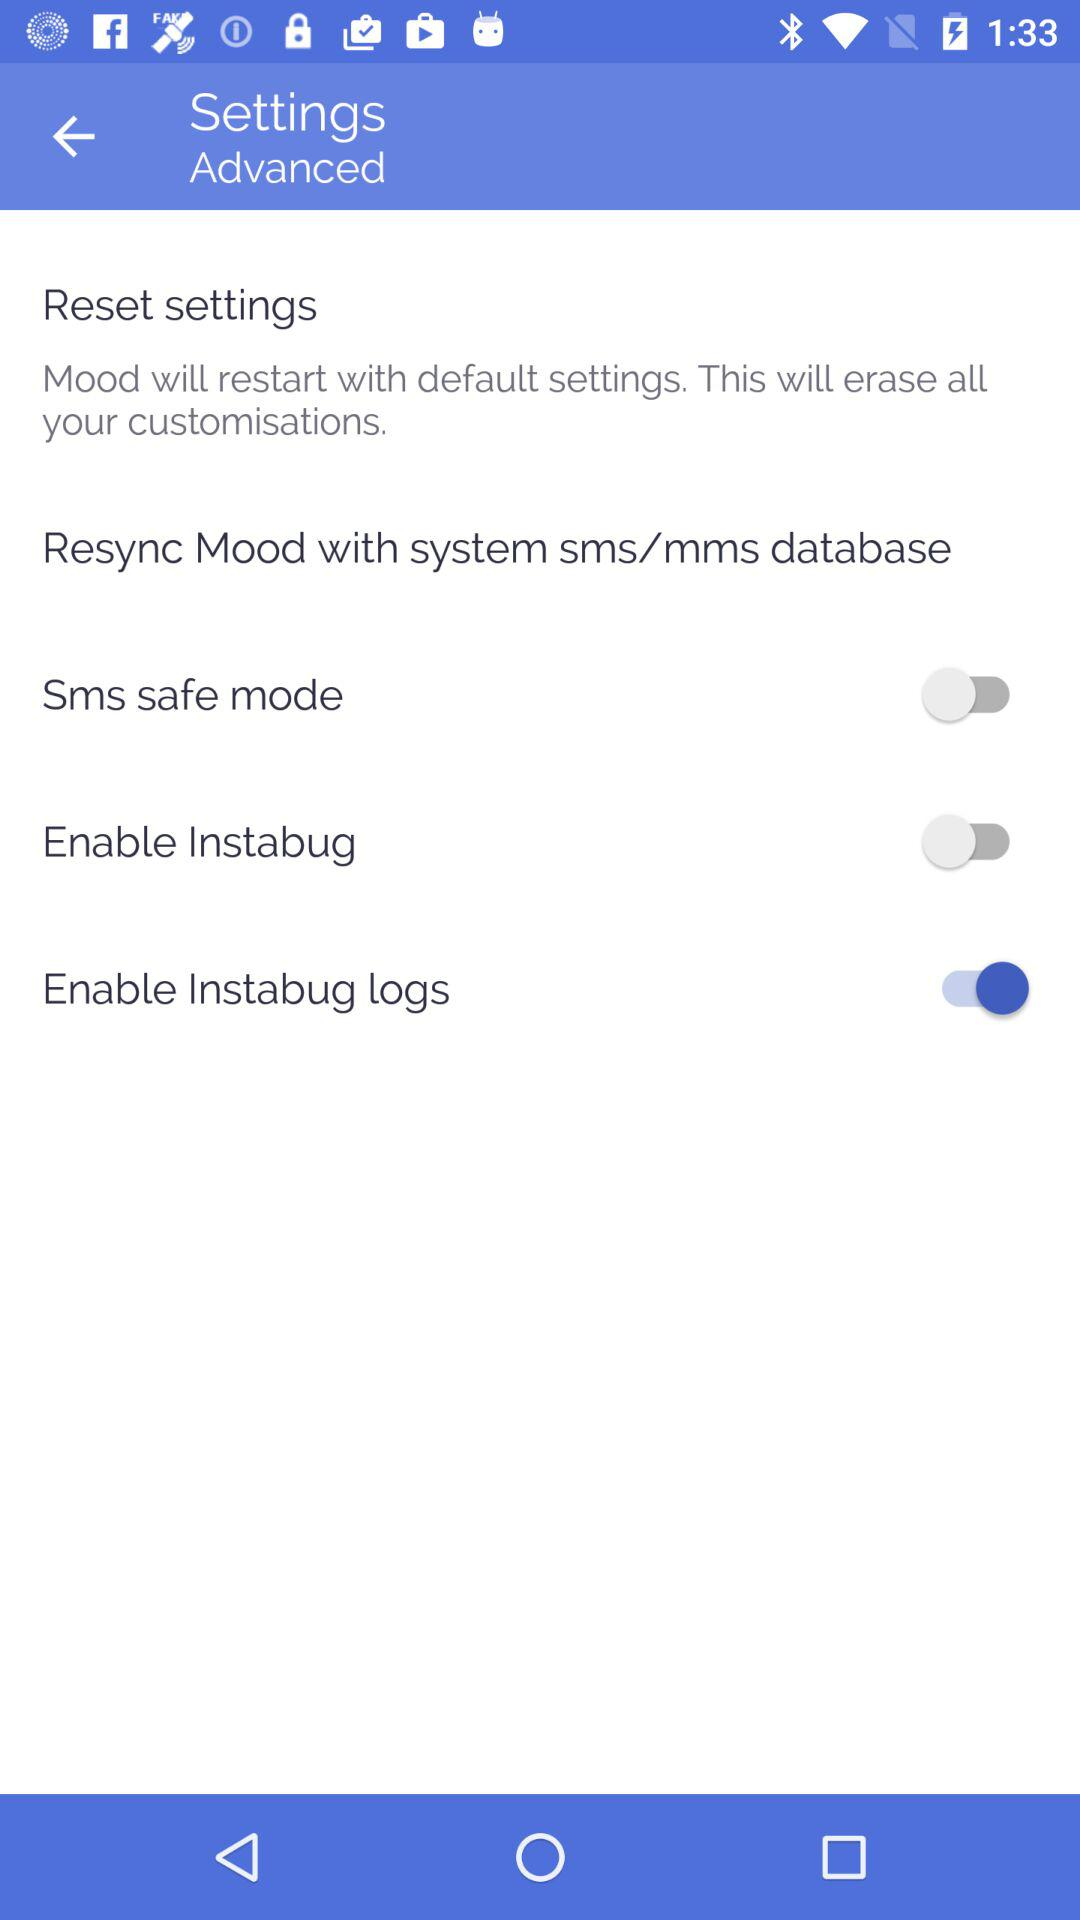How many switches are in the advanced settings section?
Answer the question using a single word or phrase. 3 